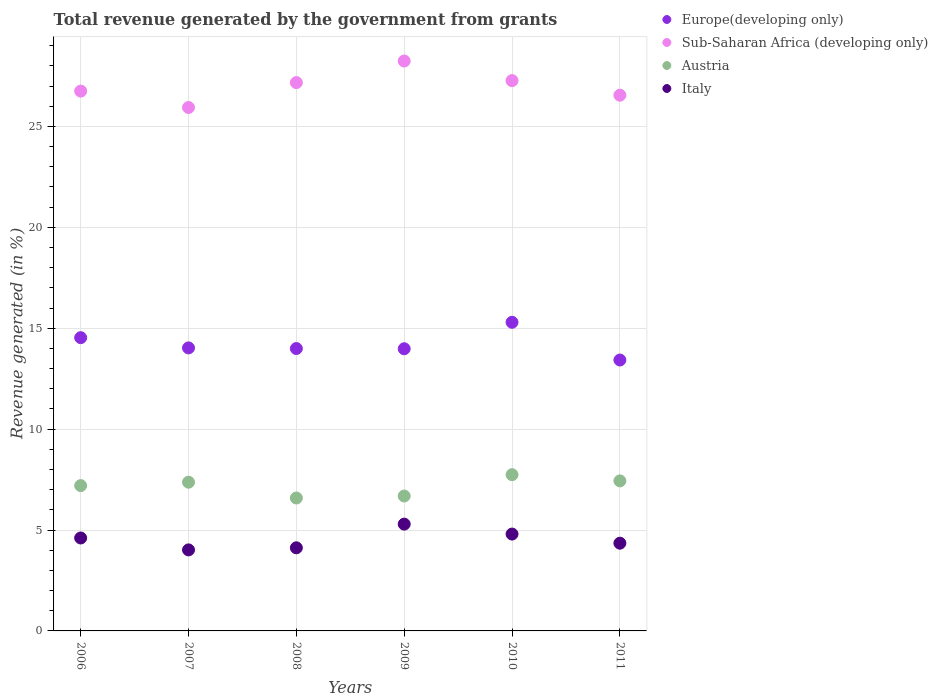How many different coloured dotlines are there?
Your response must be concise. 4. Is the number of dotlines equal to the number of legend labels?
Make the answer very short. Yes. What is the total revenue generated in Italy in 2007?
Offer a very short reply. 4.01. Across all years, what is the maximum total revenue generated in Europe(developing only)?
Offer a very short reply. 15.29. Across all years, what is the minimum total revenue generated in Italy?
Ensure brevity in your answer.  4.01. In which year was the total revenue generated in Italy minimum?
Your answer should be compact. 2007. What is the total total revenue generated in Austria in the graph?
Your answer should be compact. 43.02. What is the difference between the total revenue generated in Italy in 2009 and that in 2010?
Make the answer very short. 0.49. What is the difference between the total revenue generated in Sub-Saharan Africa (developing only) in 2006 and the total revenue generated in Italy in 2007?
Ensure brevity in your answer.  22.73. What is the average total revenue generated in Italy per year?
Offer a very short reply. 4.53. In the year 2007, what is the difference between the total revenue generated in Sub-Saharan Africa (developing only) and total revenue generated in Europe(developing only)?
Offer a very short reply. 11.91. In how many years, is the total revenue generated in Austria greater than 20 %?
Your answer should be very brief. 0. What is the ratio of the total revenue generated in Sub-Saharan Africa (developing only) in 2009 to that in 2011?
Provide a short and direct response. 1.06. Is the total revenue generated in Sub-Saharan Africa (developing only) in 2007 less than that in 2009?
Ensure brevity in your answer.  Yes. Is the difference between the total revenue generated in Sub-Saharan Africa (developing only) in 2008 and 2010 greater than the difference between the total revenue generated in Europe(developing only) in 2008 and 2010?
Make the answer very short. Yes. What is the difference between the highest and the second highest total revenue generated in Sub-Saharan Africa (developing only)?
Your response must be concise. 0.97. What is the difference between the highest and the lowest total revenue generated in Italy?
Offer a terse response. 1.28. Is the sum of the total revenue generated in Austria in 2007 and 2008 greater than the maximum total revenue generated in Europe(developing only) across all years?
Your response must be concise. No. Is it the case that in every year, the sum of the total revenue generated in Austria and total revenue generated in Italy  is greater than the total revenue generated in Sub-Saharan Africa (developing only)?
Provide a succinct answer. No. Does the total revenue generated in Austria monotonically increase over the years?
Provide a short and direct response. No. How many dotlines are there?
Offer a terse response. 4. What is the difference between two consecutive major ticks on the Y-axis?
Offer a very short reply. 5. Are the values on the major ticks of Y-axis written in scientific E-notation?
Offer a terse response. No. Where does the legend appear in the graph?
Offer a terse response. Top right. How are the legend labels stacked?
Provide a short and direct response. Vertical. What is the title of the graph?
Your answer should be very brief. Total revenue generated by the government from grants. Does "Liberia" appear as one of the legend labels in the graph?
Your answer should be very brief. No. What is the label or title of the X-axis?
Offer a very short reply. Years. What is the label or title of the Y-axis?
Provide a succinct answer. Revenue generated (in %). What is the Revenue generated (in %) of Europe(developing only) in 2006?
Your answer should be very brief. 14.53. What is the Revenue generated (in %) in Sub-Saharan Africa (developing only) in 2006?
Provide a short and direct response. 26.75. What is the Revenue generated (in %) in Austria in 2006?
Your response must be concise. 7.2. What is the Revenue generated (in %) in Italy in 2006?
Your answer should be compact. 4.61. What is the Revenue generated (in %) of Europe(developing only) in 2007?
Provide a succinct answer. 14.02. What is the Revenue generated (in %) in Sub-Saharan Africa (developing only) in 2007?
Keep it short and to the point. 25.94. What is the Revenue generated (in %) in Austria in 2007?
Provide a short and direct response. 7.37. What is the Revenue generated (in %) in Italy in 2007?
Make the answer very short. 4.01. What is the Revenue generated (in %) of Europe(developing only) in 2008?
Offer a very short reply. 13.99. What is the Revenue generated (in %) of Sub-Saharan Africa (developing only) in 2008?
Ensure brevity in your answer.  27.17. What is the Revenue generated (in %) of Austria in 2008?
Your answer should be very brief. 6.59. What is the Revenue generated (in %) in Italy in 2008?
Offer a terse response. 4.12. What is the Revenue generated (in %) of Europe(developing only) in 2009?
Keep it short and to the point. 13.98. What is the Revenue generated (in %) in Sub-Saharan Africa (developing only) in 2009?
Keep it short and to the point. 28.24. What is the Revenue generated (in %) in Austria in 2009?
Your answer should be compact. 6.68. What is the Revenue generated (in %) in Italy in 2009?
Offer a terse response. 5.29. What is the Revenue generated (in %) of Europe(developing only) in 2010?
Keep it short and to the point. 15.29. What is the Revenue generated (in %) of Sub-Saharan Africa (developing only) in 2010?
Offer a very short reply. 27.27. What is the Revenue generated (in %) in Austria in 2010?
Give a very brief answer. 7.74. What is the Revenue generated (in %) of Italy in 2010?
Offer a terse response. 4.8. What is the Revenue generated (in %) of Europe(developing only) in 2011?
Your response must be concise. 13.42. What is the Revenue generated (in %) in Sub-Saharan Africa (developing only) in 2011?
Your response must be concise. 26.54. What is the Revenue generated (in %) of Austria in 2011?
Provide a short and direct response. 7.43. What is the Revenue generated (in %) of Italy in 2011?
Ensure brevity in your answer.  4.35. Across all years, what is the maximum Revenue generated (in %) in Europe(developing only)?
Provide a short and direct response. 15.29. Across all years, what is the maximum Revenue generated (in %) of Sub-Saharan Africa (developing only)?
Keep it short and to the point. 28.24. Across all years, what is the maximum Revenue generated (in %) in Austria?
Offer a terse response. 7.74. Across all years, what is the maximum Revenue generated (in %) in Italy?
Your response must be concise. 5.29. Across all years, what is the minimum Revenue generated (in %) in Europe(developing only)?
Your response must be concise. 13.42. Across all years, what is the minimum Revenue generated (in %) of Sub-Saharan Africa (developing only)?
Your answer should be compact. 25.94. Across all years, what is the minimum Revenue generated (in %) in Austria?
Make the answer very short. 6.59. Across all years, what is the minimum Revenue generated (in %) of Italy?
Your answer should be very brief. 4.01. What is the total Revenue generated (in %) of Europe(developing only) in the graph?
Give a very brief answer. 85.24. What is the total Revenue generated (in %) of Sub-Saharan Africa (developing only) in the graph?
Provide a short and direct response. 161.9. What is the total Revenue generated (in %) in Austria in the graph?
Provide a succinct answer. 43.02. What is the total Revenue generated (in %) in Italy in the graph?
Your answer should be compact. 27.18. What is the difference between the Revenue generated (in %) in Europe(developing only) in 2006 and that in 2007?
Ensure brevity in your answer.  0.51. What is the difference between the Revenue generated (in %) in Sub-Saharan Africa (developing only) in 2006 and that in 2007?
Give a very brief answer. 0.81. What is the difference between the Revenue generated (in %) in Austria in 2006 and that in 2007?
Make the answer very short. -0.17. What is the difference between the Revenue generated (in %) in Italy in 2006 and that in 2007?
Give a very brief answer. 0.59. What is the difference between the Revenue generated (in %) in Europe(developing only) in 2006 and that in 2008?
Provide a succinct answer. 0.54. What is the difference between the Revenue generated (in %) of Sub-Saharan Africa (developing only) in 2006 and that in 2008?
Make the answer very short. -0.42. What is the difference between the Revenue generated (in %) of Austria in 2006 and that in 2008?
Offer a terse response. 0.61. What is the difference between the Revenue generated (in %) of Italy in 2006 and that in 2008?
Offer a very short reply. 0.49. What is the difference between the Revenue generated (in %) of Europe(developing only) in 2006 and that in 2009?
Your answer should be compact. 0.55. What is the difference between the Revenue generated (in %) in Sub-Saharan Africa (developing only) in 2006 and that in 2009?
Provide a short and direct response. -1.49. What is the difference between the Revenue generated (in %) of Austria in 2006 and that in 2009?
Offer a terse response. 0.52. What is the difference between the Revenue generated (in %) in Italy in 2006 and that in 2009?
Give a very brief answer. -0.69. What is the difference between the Revenue generated (in %) in Europe(developing only) in 2006 and that in 2010?
Give a very brief answer. -0.76. What is the difference between the Revenue generated (in %) in Sub-Saharan Africa (developing only) in 2006 and that in 2010?
Provide a short and direct response. -0.52. What is the difference between the Revenue generated (in %) in Austria in 2006 and that in 2010?
Give a very brief answer. -0.54. What is the difference between the Revenue generated (in %) of Italy in 2006 and that in 2010?
Your response must be concise. -0.19. What is the difference between the Revenue generated (in %) in Europe(developing only) in 2006 and that in 2011?
Your response must be concise. 1.11. What is the difference between the Revenue generated (in %) in Sub-Saharan Africa (developing only) in 2006 and that in 2011?
Your answer should be very brief. 0.2. What is the difference between the Revenue generated (in %) of Austria in 2006 and that in 2011?
Ensure brevity in your answer.  -0.23. What is the difference between the Revenue generated (in %) in Italy in 2006 and that in 2011?
Make the answer very short. 0.26. What is the difference between the Revenue generated (in %) in Europe(developing only) in 2007 and that in 2008?
Keep it short and to the point. 0.03. What is the difference between the Revenue generated (in %) of Sub-Saharan Africa (developing only) in 2007 and that in 2008?
Offer a terse response. -1.23. What is the difference between the Revenue generated (in %) in Austria in 2007 and that in 2008?
Provide a short and direct response. 0.78. What is the difference between the Revenue generated (in %) in Italy in 2007 and that in 2008?
Your response must be concise. -0.1. What is the difference between the Revenue generated (in %) of Europe(developing only) in 2007 and that in 2009?
Offer a very short reply. 0.04. What is the difference between the Revenue generated (in %) in Sub-Saharan Africa (developing only) in 2007 and that in 2009?
Offer a terse response. -2.3. What is the difference between the Revenue generated (in %) of Austria in 2007 and that in 2009?
Provide a short and direct response. 0.69. What is the difference between the Revenue generated (in %) in Italy in 2007 and that in 2009?
Your response must be concise. -1.28. What is the difference between the Revenue generated (in %) in Europe(developing only) in 2007 and that in 2010?
Your response must be concise. -1.27. What is the difference between the Revenue generated (in %) of Sub-Saharan Africa (developing only) in 2007 and that in 2010?
Provide a short and direct response. -1.33. What is the difference between the Revenue generated (in %) in Austria in 2007 and that in 2010?
Provide a short and direct response. -0.37. What is the difference between the Revenue generated (in %) in Italy in 2007 and that in 2010?
Your answer should be very brief. -0.78. What is the difference between the Revenue generated (in %) in Europe(developing only) in 2007 and that in 2011?
Your answer should be compact. 0.6. What is the difference between the Revenue generated (in %) of Sub-Saharan Africa (developing only) in 2007 and that in 2011?
Offer a terse response. -0.61. What is the difference between the Revenue generated (in %) in Austria in 2007 and that in 2011?
Give a very brief answer. -0.07. What is the difference between the Revenue generated (in %) of Italy in 2007 and that in 2011?
Provide a short and direct response. -0.33. What is the difference between the Revenue generated (in %) in Europe(developing only) in 2008 and that in 2009?
Provide a succinct answer. 0.01. What is the difference between the Revenue generated (in %) in Sub-Saharan Africa (developing only) in 2008 and that in 2009?
Your answer should be very brief. -1.07. What is the difference between the Revenue generated (in %) in Austria in 2008 and that in 2009?
Your answer should be very brief. -0.1. What is the difference between the Revenue generated (in %) in Italy in 2008 and that in 2009?
Keep it short and to the point. -1.17. What is the difference between the Revenue generated (in %) of Europe(developing only) in 2008 and that in 2010?
Make the answer very short. -1.3. What is the difference between the Revenue generated (in %) of Sub-Saharan Africa (developing only) in 2008 and that in 2010?
Give a very brief answer. -0.1. What is the difference between the Revenue generated (in %) in Austria in 2008 and that in 2010?
Offer a terse response. -1.15. What is the difference between the Revenue generated (in %) in Italy in 2008 and that in 2010?
Offer a terse response. -0.68. What is the difference between the Revenue generated (in %) of Europe(developing only) in 2008 and that in 2011?
Ensure brevity in your answer.  0.57. What is the difference between the Revenue generated (in %) in Sub-Saharan Africa (developing only) in 2008 and that in 2011?
Your response must be concise. 0.62. What is the difference between the Revenue generated (in %) in Austria in 2008 and that in 2011?
Offer a terse response. -0.85. What is the difference between the Revenue generated (in %) in Italy in 2008 and that in 2011?
Offer a very short reply. -0.23. What is the difference between the Revenue generated (in %) in Europe(developing only) in 2009 and that in 2010?
Give a very brief answer. -1.31. What is the difference between the Revenue generated (in %) of Sub-Saharan Africa (developing only) in 2009 and that in 2010?
Give a very brief answer. 0.97. What is the difference between the Revenue generated (in %) of Austria in 2009 and that in 2010?
Provide a succinct answer. -1.06. What is the difference between the Revenue generated (in %) of Italy in 2009 and that in 2010?
Your answer should be compact. 0.49. What is the difference between the Revenue generated (in %) of Europe(developing only) in 2009 and that in 2011?
Your answer should be compact. 0.56. What is the difference between the Revenue generated (in %) of Sub-Saharan Africa (developing only) in 2009 and that in 2011?
Provide a succinct answer. 1.69. What is the difference between the Revenue generated (in %) in Austria in 2009 and that in 2011?
Your answer should be very brief. -0.75. What is the difference between the Revenue generated (in %) in Italy in 2009 and that in 2011?
Give a very brief answer. 0.94. What is the difference between the Revenue generated (in %) of Europe(developing only) in 2010 and that in 2011?
Provide a succinct answer. 1.87. What is the difference between the Revenue generated (in %) of Sub-Saharan Africa (developing only) in 2010 and that in 2011?
Give a very brief answer. 0.72. What is the difference between the Revenue generated (in %) in Austria in 2010 and that in 2011?
Provide a succinct answer. 0.31. What is the difference between the Revenue generated (in %) in Italy in 2010 and that in 2011?
Ensure brevity in your answer.  0.45. What is the difference between the Revenue generated (in %) of Europe(developing only) in 2006 and the Revenue generated (in %) of Sub-Saharan Africa (developing only) in 2007?
Offer a very short reply. -11.4. What is the difference between the Revenue generated (in %) in Europe(developing only) in 2006 and the Revenue generated (in %) in Austria in 2007?
Ensure brevity in your answer.  7.16. What is the difference between the Revenue generated (in %) in Europe(developing only) in 2006 and the Revenue generated (in %) in Italy in 2007?
Offer a terse response. 10.52. What is the difference between the Revenue generated (in %) of Sub-Saharan Africa (developing only) in 2006 and the Revenue generated (in %) of Austria in 2007?
Provide a succinct answer. 19.38. What is the difference between the Revenue generated (in %) in Sub-Saharan Africa (developing only) in 2006 and the Revenue generated (in %) in Italy in 2007?
Give a very brief answer. 22.73. What is the difference between the Revenue generated (in %) in Austria in 2006 and the Revenue generated (in %) in Italy in 2007?
Provide a succinct answer. 3.18. What is the difference between the Revenue generated (in %) of Europe(developing only) in 2006 and the Revenue generated (in %) of Sub-Saharan Africa (developing only) in 2008?
Provide a succinct answer. -12.64. What is the difference between the Revenue generated (in %) in Europe(developing only) in 2006 and the Revenue generated (in %) in Austria in 2008?
Provide a short and direct response. 7.94. What is the difference between the Revenue generated (in %) of Europe(developing only) in 2006 and the Revenue generated (in %) of Italy in 2008?
Provide a short and direct response. 10.41. What is the difference between the Revenue generated (in %) of Sub-Saharan Africa (developing only) in 2006 and the Revenue generated (in %) of Austria in 2008?
Offer a terse response. 20.16. What is the difference between the Revenue generated (in %) in Sub-Saharan Africa (developing only) in 2006 and the Revenue generated (in %) in Italy in 2008?
Give a very brief answer. 22.63. What is the difference between the Revenue generated (in %) of Austria in 2006 and the Revenue generated (in %) of Italy in 2008?
Offer a very short reply. 3.08. What is the difference between the Revenue generated (in %) of Europe(developing only) in 2006 and the Revenue generated (in %) of Sub-Saharan Africa (developing only) in 2009?
Ensure brevity in your answer.  -13.71. What is the difference between the Revenue generated (in %) of Europe(developing only) in 2006 and the Revenue generated (in %) of Austria in 2009?
Your answer should be very brief. 7.85. What is the difference between the Revenue generated (in %) of Europe(developing only) in 2006 and the Revenue generated (in %) of Italy in 2009?
Your answer should be compact. 9.24. What is the difference between the Revenue generated (in %) of Sub-Saharan Africa (developing only) in 2006 and the Revenue generated (in %) of Austria in 2009?
Your answer should be very brief. 20.06. What is the difference between the Revenue generated (in %) in Sub-Saharan Africa (developing only) in 2006 and the Revenue generated (in %) in Italy in 2009?
Provide a succinct answer. 21.46. What is the difference between the Revenue generated (in %) of Austria in 2006 and the Revenue generated (in %) of Italy in 2009?
Your answer should be very brief. 1.91. What is the difference between the Revenue generated (in %) of Europe(developing only) in 2006 and the Revenue generated (in %) of Sub-Saharan Africa (developing only) in 2010?
Give a very brief answer. -12.74. What is the difference between the Revenue generated (in %) in Europe(developing only) in 2006 and the Revenue generated (in %) in Austria in 2010?
Your answer should be compact. 6.79. What is the difference between the Revenue generated (in %) of Europe(developing only) in 2006 and the Revenue generated (in %) of Italy in 2010?
Your answer should be compact. 9.73. What is the difference between the Revenue generated (in %) of Sub-Saharan Africa (developing only) in 2006 and the Revenue generated (in %) of Austria in 2010?
Offer a very short reply. 19.01. What is the difference between the Revenue generated (in %) of Sub-Saharan Africa (developing only) in 2006 and the Revenue generated (in %) of Italy in 2010?
Your response must be concise. 21.95. What is the difference between the Revenue generated (in %) in Austria in 2006 and the Revenue generated (in %) in Italy in 2010?
Provide a succinct answer. 2.4. What is the difference between the Revenue generated (in %) of Europe(developing only) in 2006 and the Revenue generated (in %) of Sub-Saharan Africa (developing only) in 2011?
Offer a very short reply. -12.01. What is the difference between the Revenue generated (in %) in Europe(developing only) in 2006 and the Revenue generated (in %) in Austria in 2011?
Give a very brief answer. 7.1. What is the difference between the Revenue generated (in %) of Europe(developing only) in 2006 and the Revenue generated (in %) of Italy in 2011?
Provide a succinct answer. 10.18. What is the difference between the Revenue generated (in %) of Sub-Saharan Africa (developing only) in 2006 and the Revenue generated (in %) of Austria in 2011?
Your answer should be very brief. 19.31. What is the difference between the Revenue generated (in %) of Sub-Saharan Africa (developing only) in 2006 and the Revenue generated (in %) of Italy in 2011?
Make the answer very short. 22.4. What is the difference between the Revenue generated (in %) of Austria in 2006 and the Revenue generated (in %) of Italy in 2011?
Provide a short and direct response. 2.85. What is the difference between the Revenue generated (in %) in Europe(developing only) in 2007 and the Revenue generated (in %) in Sub-Saharan Africa (developing only) in 2008?
Keep it short and to the point. -13.15. What is the difference between the Revenue generated (in %) in Europe(developing only) in 2007 and the Revenue generated (in %) in Austria in 2008?
Offer a terse response. 7.44. What is the difference between the Revenue generated (in %) in Europe(developing only) in 2007 and the Revenue generated (in %) in Italy in 2008?
Make the answer very short. 9.91. What is the difference between the Revenue generated (in %) in Sub-Saharan Africa (developing only) in 2007 and the Revenue generated (in %) in Austria in 2008?
Ensure brevity in your answer.  19.35. What is the difference between the Revenue generated (in %) of Sub-Saharan Africa (developing only) in 2007 and the Revenue generated (in %) of Italy in 2008?
Offer a terse response. 21.82. What is the difference between the Revenue generated (in %) of Austria in 2007 and the Revenue generated (in %) of Italy in 2008?
Provide a succinct answer. 3.25. What is the difference between the Revenue generated (in %) of Europe(developing only) in 2007 and the Revenue generated (in %) of Sub-Saharan Africa (developing only) in 2009?
Offer a terse response. -14.21. What is the difference between the Revenue generated (in %) of Europe(developing only) in 2007 and the Revenue generated (in %) of Austria in 2009?
Your answer should be compact. 7.34. What is the difference between the Revenue generated (in %) in Europe(developing only) in 2007 and the Revenue generated (in %) in Italy in 2009?
Offer a very short reply. 8.73. What is the difference between the Revenue generated (in %) of Sub-Saharan Africa (developing only) in 2007 and the Revenue generated (in %) of Austria in 2009?
Give a very brief answer. 19.25. What is the difference between the Revenue generated (in %) in Sub-Saharan Africa (developing only) in 2007 and the Revenue generated (in %) in Italy in 2009?
Give a very brief answer. 20.64. What is the difference between the Revenue generated (in %) of Austria in 2007 and the Revenue generated (in %) of Italy in 2009?
Provide a succinct answer. 2.08. What is the difference between the Revenue generated (in %) in Europe(developing only) in 2007 and the Revenue generated (in %) in Sub-Saharan Africa (developing only) in 2010?
Make the answer very short. -13.25. What is the difference between the Revenue generated (in %) of Europe(developing only) in 2007 and the Revenue generated (in %) of Austria in 2010?
Give a very brief answer. 6.28. What is the difference between the Revenue generated (in %) in Europe(developing only) in 2007 and the Revenue generated (in %) in Italy in 2010?
Provide a short and direct response. 9.22. What is the difference between the Revenue generated (in %) in Sub-Saharan Africa (developing only) in 2007 and the Revenue generated (in %) in Austria in 2010?
Offer a very short reply. 18.19. What is the difference between the Revenue generated (in %) of Sub-Saharan Africa (developing only) in 2007 and the Revenue generated (in %) of Italy in 2010?
Ensure brevity in your answer.  21.14. What is the difference between the Revenue generated (in %) of Austria in 2007 and the Revenue generated (in %) of Italy in 2010?
Offer a terse response. 2.57. What is the difference between the Revenue generated (in %) in Europe(developing only) in 2007 and the Revenue generated (in %) in Sub-Saharan Africa (developing only) in 2011?
Your response must be concise. -12.52. What is the difference between the Revenue generated (in %) of Europe(developing only) in 2007 and the Revenue generated (in %) of Austria in 2011?
Offer a very short reply. 6.59. What is the difference between the Revenue generated (in %) in Europe(developing only) in 2007 and the Revenue generated (in %) in Italy in 2011?
Offer a very short reply. 9.68. What is the difference between the Revenue generated (in %) of Sub-Saharan Africa (developing only) in 2007 and the Revenue generated (in %) of Austria in 2011?
Your answer should be very brief. 18.5. What is the difference between the Revenue generated (in %) of Sub-Saharan Africa (developing only) in 2007 and the Revenue generated (in %) of Italy in 2011?
Provide a succinct answer. 21.59. What is the difference between the Revenue generated (in %) in Austria in 2007 and the Revenue generated (in %) in Italy in 2011?
Provide a short and direct response. 3.02. What is the difference between the Revenue generated (in %) in Europe(developing only) in 2008 and the Revenue generated (in %) in Sub-Saharan Africa (developing only) in 2009?
Give a very brief answer. -14.25. What is the difference between the Revenue generated (in %) of Europe(developing only) in 2008 and the Revenue generated (in %) of Austria in 2009?
Offer a very short reply. 7.31. What is the difference between the Revenue generated (in %) of Europe(developing only) in 2008 and the Revenue generated (in %) of Italy in 2009?
Your answer should be very brief. 8.7. What is the difference between the Revenue generated (in %) in Sub-Saharan Africa (developing only) in 2008 and the Revenue generated (in %) in Austria in 2009?
Your answer should be compact. 20.48. What is the difference between the Revenue generated (in %) in Sub-Saharan Africa (developing only) in 2008 and the Revenue generated (in %) in Italy in 2009?
Provide a succinct answer. 21.88. What is the difference between the Revenue generated (in %) in Austria in 2008 and the Revenue generated (in %) in Italy in 2009?
Give a very brief answer. 1.29. What is the difference between the Revenue generated (in %) of Europe(developing only) in 2008 and the Revenue generated (in %) of Sub-Saharan Africa (developing only) in 2010?
Offer a very short reply. -13.28. What is the difference between the Revenue generated (in %) in Europe(developing only) in 2008 and the Revenue generated (in %) in Austria in 2010?
Provide a short and direct response. 6.25. What is the difference between the Revenue generated (in %) of Europe(developing only) in 2008 and the Revenue generated (in %) of Italy in 2010?
Ensure brevity in your answer.  9.19. What is the difference between the Revenue generated (in %) in Sub-Saharan Africa (developing only) in 2008 and the Revenue generated (in %) in Austria in 2010?
Offer a terse response. 19.43. What is the difference between the Revenue generated (in %) in Sub-Saharan Africa (developing only) in 2008 and the Revenue generated (in %) in Italy in 2010?
Provide a short and direct response. 22.37. What is the difference between the Revenue generated (in %) in Austria in 2008 and the Revenue generated (in %) in Italy in 2010?
Give a very brief answer. 1.79. What is the difference between the Revenue generated (in %) in Europe(developing only) in 2008 and the Revenue generated (in %) in Sub-Saharan Africa (developing only) in 2011?
Give a very brief answer. -12.55. What is the difference between the Revenue generated (in %) of Europe(developing only) in 2008 and the Revenue generated (in %) of Austria in 2011?
Your response must be concise. 6.56. What is the difference between the Revenue generated (in %) of Europe(developing only) in 2008 and the Revenue generated (in %) of Italy in 2011?
Keep it short and to the point. 9.64. What is the difference between the Revenue generated (in %) in Sub-Saharan Africa (developing only) in 2008 and the Revenue generated (in %) in Austria in 2011?
Make the answer very short. 19.73. What is the difference between the Revenue generated (in %) in Sub-Saharan Africa (developing only) in 2008 and the Revenue generated (in %) in Italy in 2011?
Give a very brief answer. 22.82. What is the difference between the Revenue generated (in %) of Austria in 2008 and the Revenue generated (in %) of Italy in 2011?
Keep it short and to the point. 2.24. What is the difference between the Revenue generated (in %) in Europe(developing only) in 2009 and the Revenue generated (in %) in Sub-Saharan Africa (developing only) in 2010?
Ensure brevity in your answer.  -13.29. What is the difference between the Revenue generated (in %) of Europe(developing only) in 2009 and the Revenue generated (in %) of Austria in 2010?
Offer a very short reply. 6.24. What is the difference between the Revenue generated (in %) of Europe(developing only) in 2009 and the Revenue generated (in %) of Italy in 2010?
Give a very brief answer. 9.18. What is the difference between the Revenue generated (in %) of Sub-Saharan Africa (developing only) in 2009 and the Revenue generated (in %) of Austria in 2010?
Ensure brevity in your answer.  20.5. What is the difference between the Revenue generated (in %) of Sub-Saharan Africa (developing only) in 2009 and the Revenue generated (in %) of Italy in 2010?
Provide a short and direct response. 23.44. What is the difference between the Revenue generated (in %) in Austria in 2009 and the Revenue generated (in %) in Italy in 2010?
Ensure brevity in your answer.  1.88. What is the difference between the Revenue generated (in %) in Europe(developing only) in 2009 and the Revenue generated (in %) in Sub-Saharan Africa (developing only) in 2011?
Your answer should be very brief. -12.56. What is the difference between the Revenue generated (in %) of Europe(developing only) in 2009 and the Revenue generated (in %) of Austria in 2011?
Give a very brief answer. 6.55. What is the difference between the Revenue generated (in %) in Europe(developing only) in 2009 and the Revenue generated (in %) in Italy in 2011?
Offer a very short reply. 9.63. What is the difference between the Revenue generated (in %) of Sub-Saharan Africa (developing only) in 2009 and the Revenue generated (in %) of Austria in 2011?
Your response must be concise. 20.8. What is the difference between the Revenue generated (in %) in Sub-Saharan Africa (developing only) in 2009 and the Revenue generated (in %) in Italy in 2011?
Your response must be concise. 23.89. What is the difference between the Revenue generated (in %) of Austria in 2009 and the Revenue generated (in %) of Italy in 2011?
Ensure brevity in your answer.  2.34. What is the difference between the Revenue generated (in %) in Europe(developing only) in 2010 and the Revenue generated (in %) in Sub-Saharan Africa (developing only) in 2011?
Provide a short and direct response. -11.25. What is the difference between the Revenue generated (in %) in Europe(developing only) in 2010 and the Revenue generated (in %) in Austria in 2011?
Ensure brevity in your answer.  7.86. What is the difference between the Revenue generated (in %) in Europe(developing only) in 2010 and the Revenue generated (in %) in Italy in 2011?
Provide a succinct answer. 10.95. What is the difference between the Revenue generated (in %) of Sub-Saharan Africa (developing only) in 2010 and the Revenue generated (in %) of Austria in 2011?
Keep it short and to the point. 19.83. What is the difference between the Revenue generated (in %) of Sub-Saharan Africa (developing only) in 2010 and the Revenue generated (in %) of Italy in 2011?
Your answer should be very brief. 22.92. What is the difference between the Revenue generated (in %) of Austria in 2010 and the Revenue generated (in %) of Italy in 2011?
Make the answer very short. 3.39. What is the average Revenue generated (in %) of Europe(developing only) per year?
Ensure brevity in your answer.  14.21. What is the average Revenue generated (in %) in Sub-Saharan Africa (developing only) per year?
Provide a succinct answer. 26.98. What is the average Revenue generated (in %) in Austria per year?
Provide a short and direct response. 7.17. What is the average Revenue generated (in %) of Italy per year?
Your answer should be very brief. 4.53. In the year 2006, what is the difference between the Revenue generated (in %) in Europe(developing only) and Revenue generated (in %) in Sub-Saharan Africa (developing only)?
Your response must be concise. -12.22. In the year 2006, what is the difference between the Revenue generated (in %) of Europe(developing only) and Revenue generated (in %) of Austria?
Offer a terse response. 7.33. In the year 2006, what is the difference between the Revenue generated (in %) of Europe(developing only) and Revenue generated (in %) of Italy?
Offer a terse response. 9.93. In the year 2006, what is the difference between the Revenue generated (in %) in Sub-Saharan Africa (developing only) and Revenue generated (in %) in Austria?
Your answer should be compact. 19.55. In the year 2006, what is the difference between the Revenue generated (in %) of Sub-Saharan Africa (developing only) and Revenue generated (in %) of Italy?
Give a very brief answer. 22.14. In the year 2006, what is the difference between the Revenue generated (in %) in Austria and Revenue generated (in %) in Italy?
Provide a short and direct response. 2.59. In the year 2007, what is the difference between the Revenue generated (in %) of Europe(developing only) and Revenue generated (in %) of Sub-Saharan Africa (developing only)?
Provide a short and direct response. -11.91. In the year 2007, what is the difference between the Revenue generated (in %) of Europe(developing only) and Revenue generated (in %) of Austria?
Your answer should be compact. 6.65. In the year 2007, what is the difference between the Revenue generated (in %) in Europe(developing only) and Revenue generated (in %) in Italy?
Give a very brief answer. 10.01. In the year 2007, what is the difference between the Revenue generated (in %) in Sub-Saharan Africa (developing only) and Revenue generated (in %) in Austria?
Offer a very short reply. 18.57. In the year 2007, what is the difference between the Revenue generated (in %) in Sub-Saharan Africa (developing only) and Revenue generated (in %) in Italy?
Offer a very short reply. 21.92. In the year 2007, what is the difference between the Revenue generated (in %) in Austria and Revenue generated (in %) in Italy?
Offer a very short reply. 3.35. In the year 2008, what is the difference between the Revenue generated (in %) of Europe(developing only) and Revenue generated (in %) of Sub-Saharan Africa (developing only)?
Your answer should be compact. -13.18. In the year 2008, what is the difference between the Revenue generated (in %) in Europe(developing only) and Revenue generated (in %) in Austria?
Offer a terse response. 7.41. In the year 2008, what is the difference between the Revenue generated (in %) of Europe(developing only) and Revenue generated (in %) of Italy?
Make the answer very short. 9.87. In the year 2008, what is the difference between the Revenue generated (in %) in Sub-Saharan Africa (developing only) and Revenue generated (in %) in Austria?
Your answer should be very brief. 20.58. In the year 2008, what is the difference between the Revenue generated (in %) in Sub-Saharan Africa (developing only) and Revenue generated (in %) in Italy?
Provide a succinct answer. 23.05. In the year 2008, what is the difference between the Revenue generated (in %) of Austria and Revenue generated (in %) of Italy?
Keep it short and to the point. 2.47. In the year 2009, what is the difference between the Revenue generated (in %) in Europe(developing only) and Revenue generated (in %) in Sub-Saharan Africa (developing only)?
Provide a succinct answer. -14.26. In the year 2009, what is the difference between the Revenue generated (in %) in Europe(developing only) and Revenue generated (in %) in Austria?
Offer a very short reply. 7.3. In the year 2009, what is the difference between the Revenue generated (in %) in Europe(developing only) and Revenue generated (in %) in Italy?
Ensure brevity in your answer.  8.69. In the year 2009, what is the difference between the Revenue generated (in %) in Sub-Saharan Africa (developing only) and Revenue generated (in %) in Austria?
Make the answer very short. 21.55. In the year 2009, what is the difference between the Revenue generated (in %) of Sub-Saharan Africa (developing only) and Revenue generated (in %) of Italy?
Keep it short and to the point. 22.95. In the year 2009, what is the difference between the Revenue generated (in %) in Austria and Revenue generated (in %) in Italy?
Ensure brevity in your answer.  1.39. In the year 2010, what is the difference between the Revenue generated (in %) of Europe(developing only) and Revenue generated (in %) of Sub-Saharan Africa (developing only)?
Your answer should be compact. -11.98. In the year 2010, what is the difference between the Revenue generated (in %) of Europe(developing only) and Revenue generated (in %) of Austria?
Make the answer very short. 7.55. In the year 2010, what is the difference between the Revenue generated (in %) of Europe(developing only) and Revenue generated (in %) of Italy?
Make the answer very short. 10.49. In the year 2010, what is the difference between the Revenue generated (in %) of Sub-Saharan Africa (developing only) and Revenue generated (in %) of Austria?
Provide a succinct answer. 19.53. In the year 2010, what is the difference between the Revenue generated (in %) in Sub-Saharan Africa (developing only) and Revenue generated (in %) in Italy?
Give a very brief answer. 22.47. In the year 2010, what is the difference between the Revenue generated (in %) of Austria and Revenue generated (in %) of Italy?
Your answer should be compact. 2.94. In the year 2011, what is the difference between the Revenue generated (in %) of Europe(developing only) and Revenue generated (in %) of Sub-Saharan Africa (developing only)?
Offer a very short reply. -13.12. In the year 2011, what is the difference between the Revenue generated (in %) of Europe(developing only) and Revenue generated (in %) of Austria?
Ensure brevity in your answer.  5.99. In the year 2011, what is the difference between the Revenue generated (in %) of Europe(developing only) and Revenue generated (in %) of Italy?
Ensure brevity in your answer.  9.08. In the year 2011, what is the difference between the Revenue generated (in %) in Sub-Saharan Africa (developing only) and Revenue generated (in %) in Austria?
Provide a succinct answer. 19.11. In the year 2011, what is the difference between the Revenue generated (in %) in Sub-Saharan Africa (developing only) and Revenue generated (in %) in Italy?
Offer a terse response. 22.2. In the year 2011, what is the difference between the Revenue generated (in %) of Austria and Revenue generated (in %) of Italy?
Your answer should be very brief. 3.09. What is the ratio of the Revenue generated (in %) of Europe(developing only) in 2006 to that in 2007?
Offer a very short reply. 1.04. What is the ratio of the Revenue generated (in %) in Sub-Saharan Africa (developing only) in 2006 to that in 2007?
Keep it short and to the point. 1.03. What is the ratio of the Revenue generated (in %) in Italy in 2006 to that in 2007?
Offer a very short reply. 1.15. What is the ratio of the Revenue generated (in %) of Sub-Saharan Africa (developing only) in 2006 to that in 2008?
Give a very brief answer. 0.98. What is the ratio of the Revenue generated (in %) of Austria in 2006 to that in 2008?
Provide a succinct answer. 1.09. What is the ratio of the Revenue generated (in %) of Italy in 2006 to that in 2008?
Make the answer very short. 1.12. What is the ratio of the Revenue generated (in %) of Europe(developing only) in 2006 to that in 2009?
Provide a succinct answer. 1.04. What is the ratio of the Revenue generated (in %) of Sub-Saharan Africa (developing only) in 2006 to that in 2009?
Make the answer very short. 0.95. What is the ratio of the Revenue generated (in %) in Austria in 2006 to that in 2009?
Ensure brevity in your answer.  1.08. What is the ratio of the Revenue generated (in %) in Italy in 2006 to that in 2009?
Offer a terse response. 0.87. What is the ratio of the Revenue generated (in %) in Europe(developing only) in 2006 to that in 2010?
Ensure brevity in your answer.  0.95. What is the ratio of the Revenue generated (in %) in Sub-Saharan Africa (developing only) in 2006 to that in 2010?
Offer a very short reply. 0.98. What is the ratio of the Revenue generated (in %) of Austria in 2006 to that in 2010?
Provide a succinct answer. 0.93. What is the ratio of the Revenue generated (in %) of Italy in 2006 to that in 2010?
Make the answer very short. 0.96. What is the ratio of the Revenue generated (in %) in Europe(developing only) in 2006 to that in 2011?
Provide a short and direct response. 1.08. What is the ratio of the Revenue generated (in %) of Sub-Saharan Africa (developing only) in 2006 to that in 2011?
Provide a short and direct response. 1.01. What is the ratio of the Revenue generated (in %) in Austria in 2006 to that in 2011?
Provide a succinct answer. 0.97. What is the ratio of the Revenue generated (in %) in Italy in 2006 to that in 2011?
Ensure brevity in your answer.  1.06. What is the ratio of the Revenue generated (in %) of Sub-Saharan Africa (developing only) in 2007 to that in 2008?
Your answer should be very brief. 0.95. What is the ratio of the Revenue generated (in %) in Austria in 2007 to that in 2008?
Provide a short and direct response. 1.12. What is the ratio of the Revenue generated (in %) in Italy in 2007 to that in 2008?
Your response must be concise. 0.97. What is the ratio of the Revenue generated (in %) of Sub-Saharan Africa (developing only) in 2007 to that in 2009?
Your answer should be very brief. 0.92. What is the ratio of the Revenue generated (in %) of Austria in 2007 to that in 2009?
Your answer should be compact. 1.1. What is the ratio of the Revenue generated (in %) in Italy in 2007 to that in 2009?
Provide a succinct answer. 0.76. What is the ratio of the Revenue generated (in %) of Europe(developing only) in 2007 to that in 2010?
Provide a short and direct response. 0.92. What is the ratio of the Revenue generated (in %) of Sub-Saharan Africa (developing only) in 2007 to that in 2010?
Make the answer very short. 0.95. What is the ratio of the Revenue generated (in %) in Italy in 2007 to that in 2010?
Offer a very short reply. 0.84. What is the ratio of the Revenue generated (in %) of Europe(developing only) in 2007 to that in 2011?
Offer a very short reply. 1.04. What is the ratio of the Revenue generated (in %) in Sub-Saharan Africa (developing only) in 2007 to that in 2011?
Ensure brevity in your answer.  0.98. What is the ratio of the Revenue generated (in %) of Italy in 2007 to that in 2011?
Provide a succinct answer. 0.92. What is the ratio of the Revenue generated (in %) of Sub-Saharan Africa (developing only) in 2008 to that in 2009?
Your response must be concise. 0.96. What is the ratio of the Revenue generated (in %) in Austria in 2008 to that in 2009?
Keep it short and to the point. 0.99. What is the ratio of the Revenue generated (in %) in Italy in 2008 to that in 2009?
Provide a succinct answer. 0.78. What is the ratio of the Revenue generated (in %) of Europe(developing only) in 2008 to that in 2010?
Offer a very short reply. 0.91. What is the ratio of the Revenue generated (in %) in Austria in 2008 to that in 2010?
Your answer should be very brief. 0.85. What is the ratio of the Revenue generated (in %) of Italy in 2008 to that in 2010?
Give a very brief answer. 0.86. What is the ratio of the Revenue generated (in %) of Europe(developing only) in 2008 to that in 2011?
Your answer should be very brief. 1.04. What is the ratio of the Revenue generated (in %) in Sub-Saharan Africa (developing only) in 2008 to that in 2011?
Offer a terse response. 1.02. What is the ratio of the Revenue generated (in %) in Austria in 2008 to that in 2011?
Give a very brief answer. 0.89. What is the ratio of the Revenue generated (in %) in Italy in 2008 to that in 2011?
Your answer should be compact. 0.95. What is the ratio of the Revenue generated (in %) in Europe(developing only) in 2009 to that in 2010?
Provide a short and direct response. 0.91. What is the ratio of the Revenue generated (in %) in Sub-Saharan Africa (developing only) in 2009 to that in 2010?
Keep it short and to the point. 1.04. What is the ratio of the Revenue generated (in %) of Austria in 2009 to that in 2010?
Keep it short and to the point. 0.86. What is the ratio of the Revenue generated (in %) of Italy in 2009 to that in 2010?
Ensure brevity in your answer.  1.1. What is the ratio of the Revenue generated (in %) of Europe(developing only) in 2009 to that in 2011?
Offer a very short reply. 1.04. What is the ratio of the Revenue generated (in %) in Sub-Saharan Africa (developing only) in 2009 to that in 2011?
Your response must be concise. 1.06. What is the ratio of the Revenue generated (in %) of Austria in 2009 to that in 2011?
Provide a succinct answer. 0.9. What is the ratio of the Revenue generated (in %) of Italy in 2009 to that in 2011?
Give a very brief answer. 1.22. What is the ratio of the Revenue generated (in %) of Europe(developing only) in 2010 to that in 2011?
Keep it short and to the point. 1.14. What is the ratio of the Revenue generated (in %) of Sub-Saharan Africa (developing only) in 2010 to that in 2011?
Your response must be concise. 1.03. What is the ratio of the Revenue generated (in %) of Austria in 2010 to that in 2011?
Your answer should be compact. 1.04. What is the ratio of the Revenue generated (in %) in Italy in 2010 to that in 2011?
Offer a terse response. 1.1. What is the difference between the highest and the second highest Revenue generated (in %) of Europe(developing only)?
Provide a short and direct response. 0.76. What is the difference between the highest and the second highest Revenue generated (in %) of Sub-Saharan Africa (developing only)?
Offer a very short reply. 0.97. What is the difference between the highest and the second highest Revenue generated (in %) of Austria?
Your answer should be compact. 0.31. What is the difference between the highest and the second highest Revenue generated (in %) of Italy?
Offer a terse response. 0.49. What is the difference between the highest and the lowest Revenue generated (in %) of Europe(developing only)?
Offer a terse response. 1.87. What is the difference between the highest and the lowest Revenue generated (in %) in Sub-Saharan Africa (developing only)?
Your response must be concise. 2.3. What is the difference between the highest and the lowest Revenue generated (in %) of Austria?
Offer a very short reply. 1.15. What is the difference between the highest and the lowest Revenue generated (in %) of Italy?
Keep it short and to the point. 1.28. 